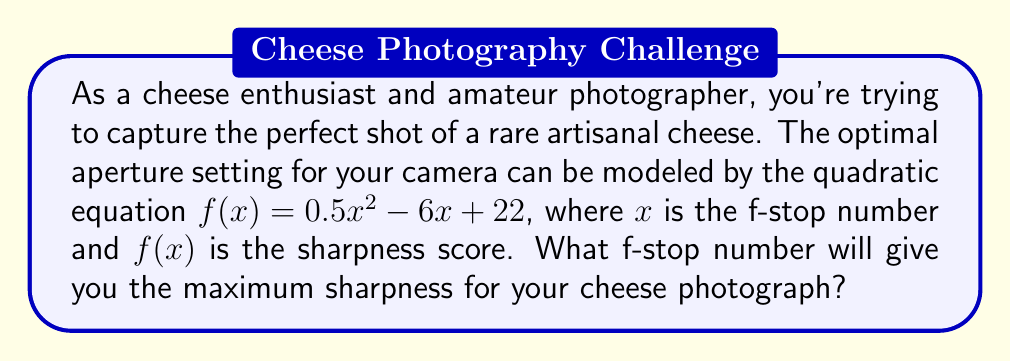Help me with this question. To find the optimal aperture setting, we need to determine the f-stop number that maximizes the sharpness score. This can be done by finding the vertex of the quadratic function.

Step 1: Identify the quadratic equation
$f(x) = 0.5x^2 - 6x + 22$

Step 2: Use the vertex formula for a quadratic function in the form $f(x) = ax^2 + bx + c$
The x-coordinate of the vertex is given by $x = -\frac{b}{2a}$

In this case:
$a = 0.5$
$b = -6$

Step 3: Calculate the x-coordinate of the vertex
$x = -\frac{(-6)}{2(0.5)} = -\frac{-6}{1} = 6$

Step 4: Verify that this is indeed a maximum by checking the sign of $a$
Since $a = 0.5 > 0$, the parabola opens upward, and the vertex represents a minimum. Therefore, $x = 6$ gives the maximum sharpness score.

Step 5: In photography, f-stop numbers are typically expressed as whole numbers or fractions. Since we got exactly 6, this corresponds to an f-stop of f/6.
Answer: f/6 